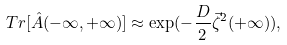Convert formula to latex. <formula><loc_0><loc_0><loc_500><loc_500>T r [ \hat { A } ( - \infty , + \infty ) ] \approx \exp ( - \frac { D } { 2 } \vec { \zeta } ^ { 2 } ( + \infty ) ) ,</formula> 